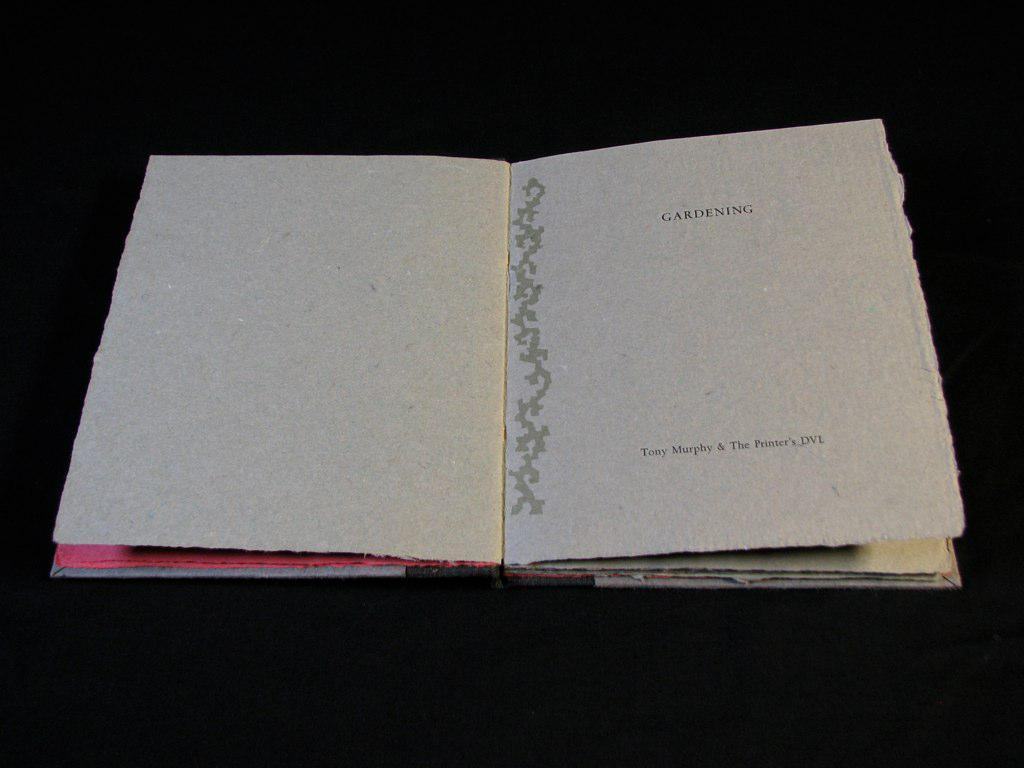<image>
Provide a brief description of the given image. the letters dvl are on the front of the paper 